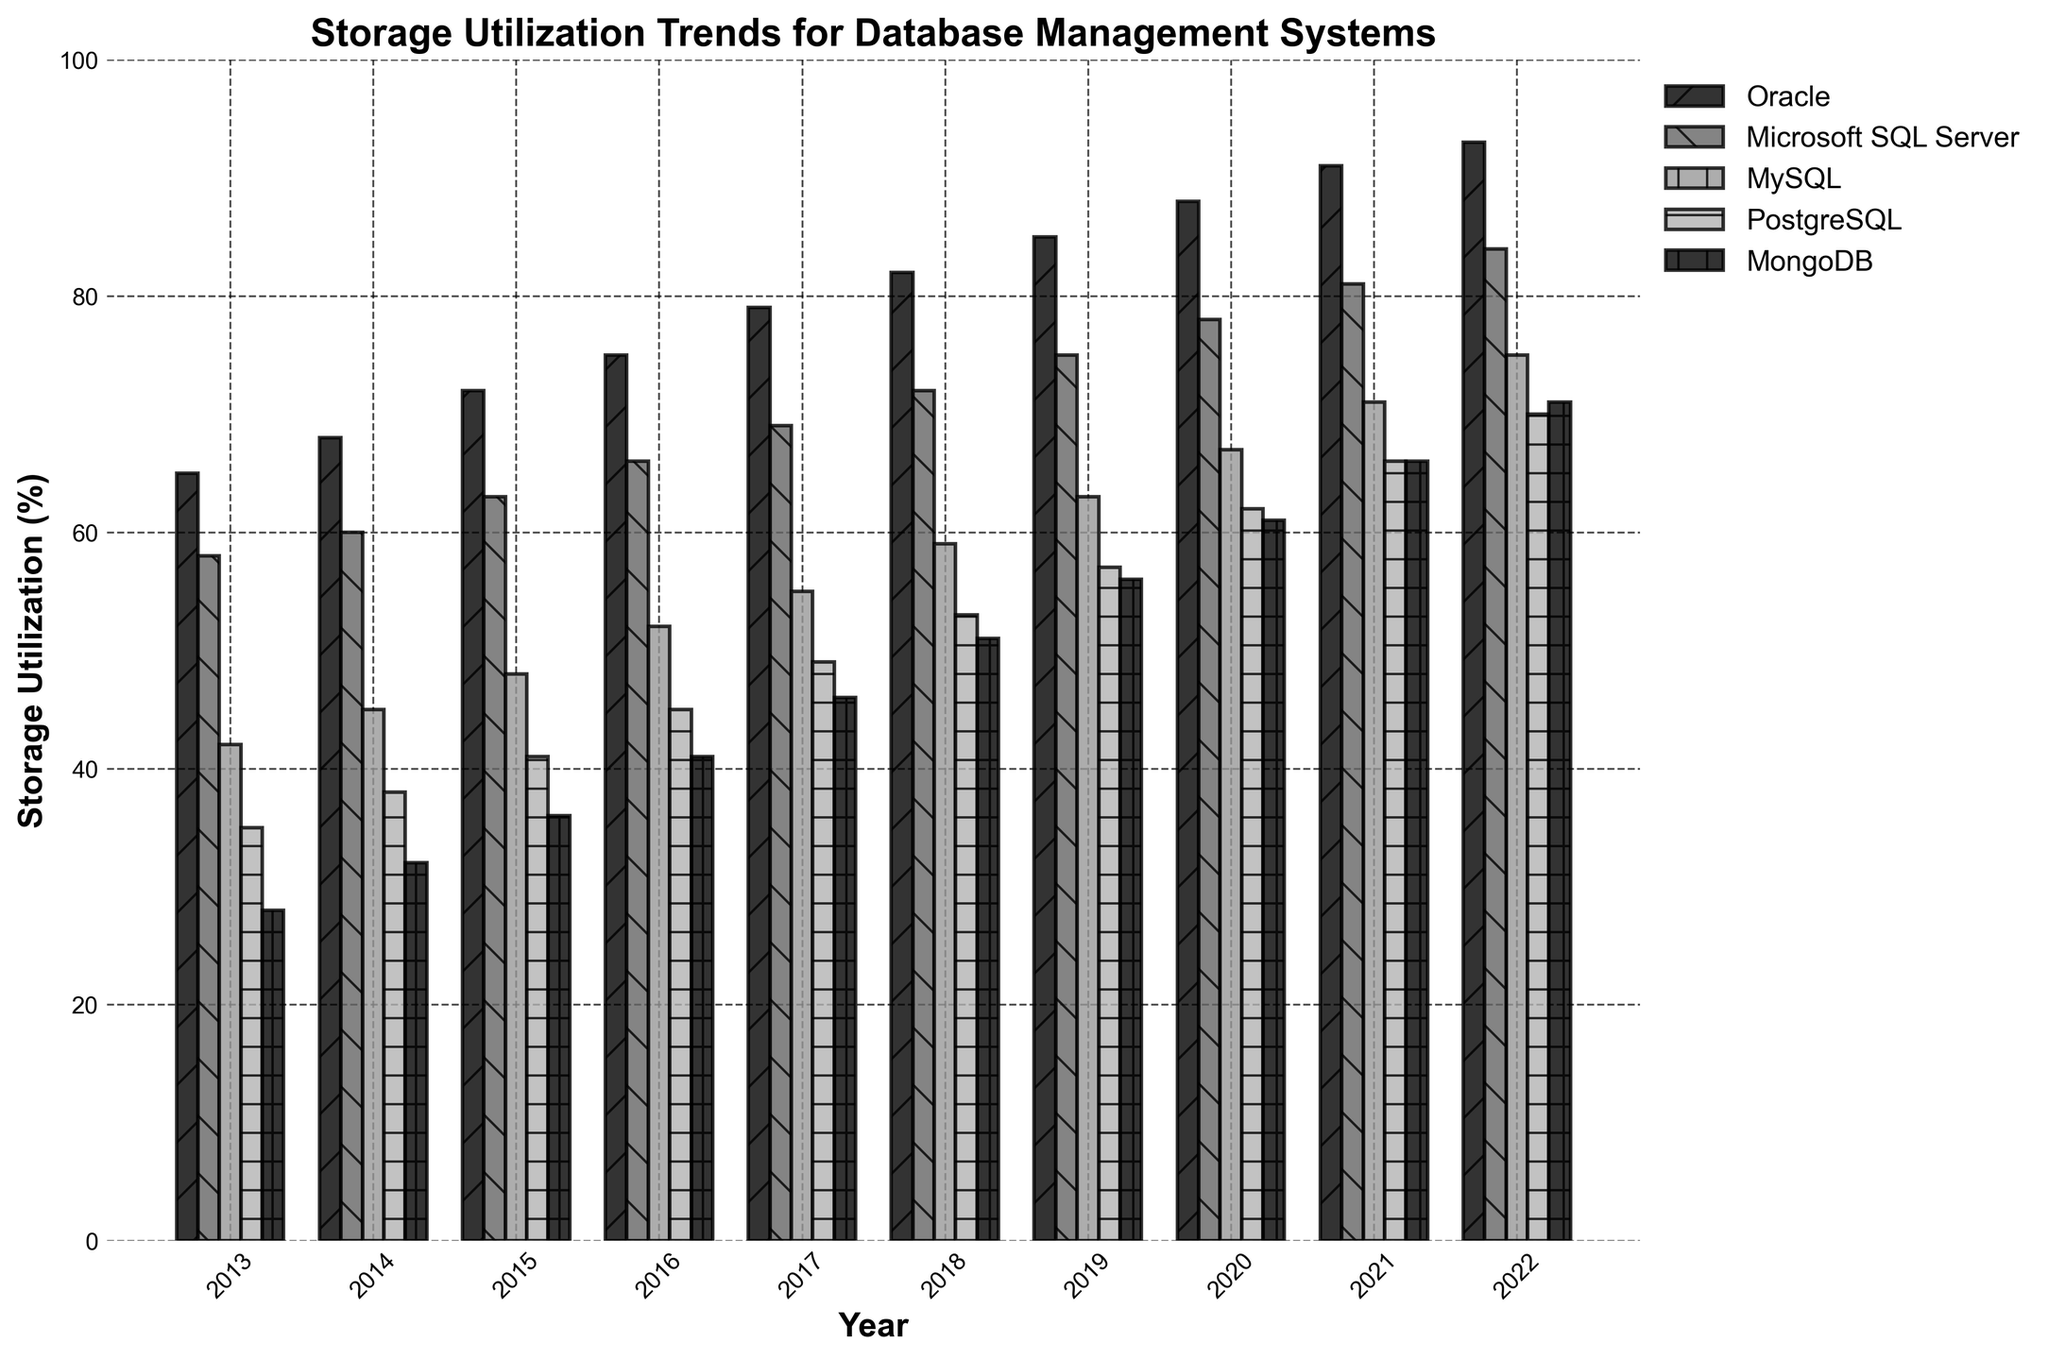What's the trend of Oracle's storage utilization over the years? From the figure, Oracle's storage utilization starts at 65% in 2013 and gradually increases in a linear fashion through each year, reaching 93% in 2022.
Answer: Steady Increase Between PostgreSQL and MongoDB, which database has a higher storage utilization in 2022? By comparing the heights of the bars labeled for PostgreSQL and MongoDB in 2022, MongoDB has a higher storage utilization than PostgreSQL.
Answer: MongoDB What's the average storage utilization of MySQL from 2013 to 2022? To find the average, sum the MySQL values from 2013 to 2022 (42 + 45 + 48 + 52 + 55 + 59 + 63 + 67 + 71 + 75 = 577), then divide by the number of years (10). Calculation: 577 / 10 = 57.7
Answer: 57.7% What is the overall trend for Microsoft SQL Server over the decade? Microsoft SQL Server shows a consistent year-on-year increase in storage utilization, from 58% in 2013 to 84% in 2022.
Answer: Steady Increase Between 2016 and 2019, which database had the largest increase in storage utilization? Calculate the difference for each database between 2016 and 2019. For Oracle: 85 - 75 = 10, SQL Server: 75 - 66 = 9, MySQL: 63 - 52 = 11, PostgreSQL: 57 - 45 = 12, MongoDB: 56 - 41 = 15. MongoDB had the largest increase of 15%.
Answer: MongoDB Which year had the smallest gap in storage utilization between Oracle and PostgreSQL? Subtract PostgreSQL values from Oracle values (2013: 30, 2014: 30, 2015: 31, 2016: 30, 2017: 30, 2018: 29, 2019: 28, 2020: 26, 2021: 25, 2022: 23). Smallest gap is 23 in 2022.
Answer: 2022 What is the significant visual difference noticeable for PostgreSQL's storage utilization compared to others? PostgreSQL consistently has shorter bars compared to Oracle, Microsoft SQL Server, and MySQL, indicating a lower storage utilization over the years, though MongoDB's bars are closer in height.
Answer: Shorter Bars In 2018, which databases have a storage utilization greater than 70%? Check the heights of bars in 2018 and see which ones are above 70%. Oracle (82) and Microsoft SQL Server (72) have values greater than 70%.
Answer: Oracle, Microsoft SQL Server Which database showed the most significant year-on-year growth in storage utilization percentage from 2021 to 2022? Calculate the difference for each database (Oracle: 2, SQL Server: 3, MySQL: 4, PostgreSQL: 4, MongoDB: 5). MongoDB had the highest growth of 5%.
Answer: MongoDB 